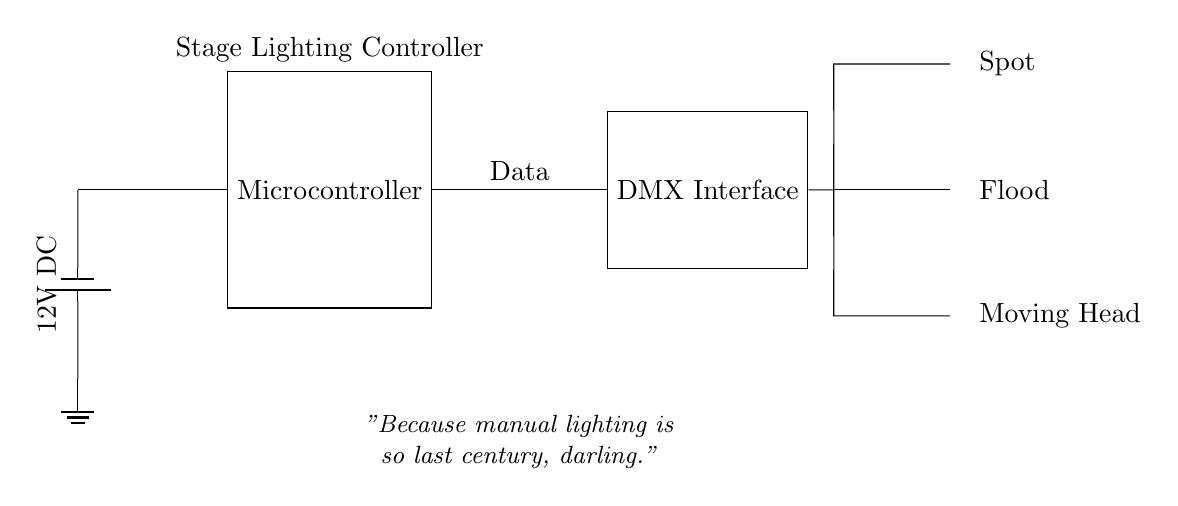what is the voltage level used in this circuit? The circuit shows a 12V DC power supply indicated by the label next to the battery symbol. It tells us the voltage that powers the system.
Answer: 12V DC what type of interface is used to control the lights? The diagram specifies a DMX Interface, which is shown as a labeled component connected to the microcontroller and the light fixtures.
Answer: DMX Interface how many light fixtures are connected to the DMX? There are three light fixtures represented in the diagram, labeled as Spot, Flood, and Moving Head, which are all connected to the DMX Interface.
Answer: Three what generates the control signals for the lighting? The microcontroller is the component that generates control signals, as it is connected to the DMX Interface, which in turn communicates with the lighting fixtures.
Answer: Microcontroller what is the function of the DMX Interface in this circuit? The DMX Interface converts data from the microcontroller into a format that the light fixtures can understand, allowing for automated control of lighting.
Answer: Automated control what type of lights are represented in the circuit? The circuit includes three types of lights: Spot, Flood, and Moving Head, as indicated by the labels next to each light fixture.
Answer: Spot, Flood, Moving Head how is the data transferred from the microcontroller to the DMX Interface? The data is transferred as a direct line connection between the microcontroller and the DMX Interface, indicated by the line that connects the two components in the circuit diagram.
Answer: Direct line connection 